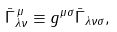<formula> <loc_0><loc_0><loc_500><loc_500>\bar { \Gamma } _ { \lambda \nu } ^ { \, \mu } \equiv g ^ { \mu \sigma } \bar { \Gamma } _ { \lambda \nu \sigma } ,</formula> 